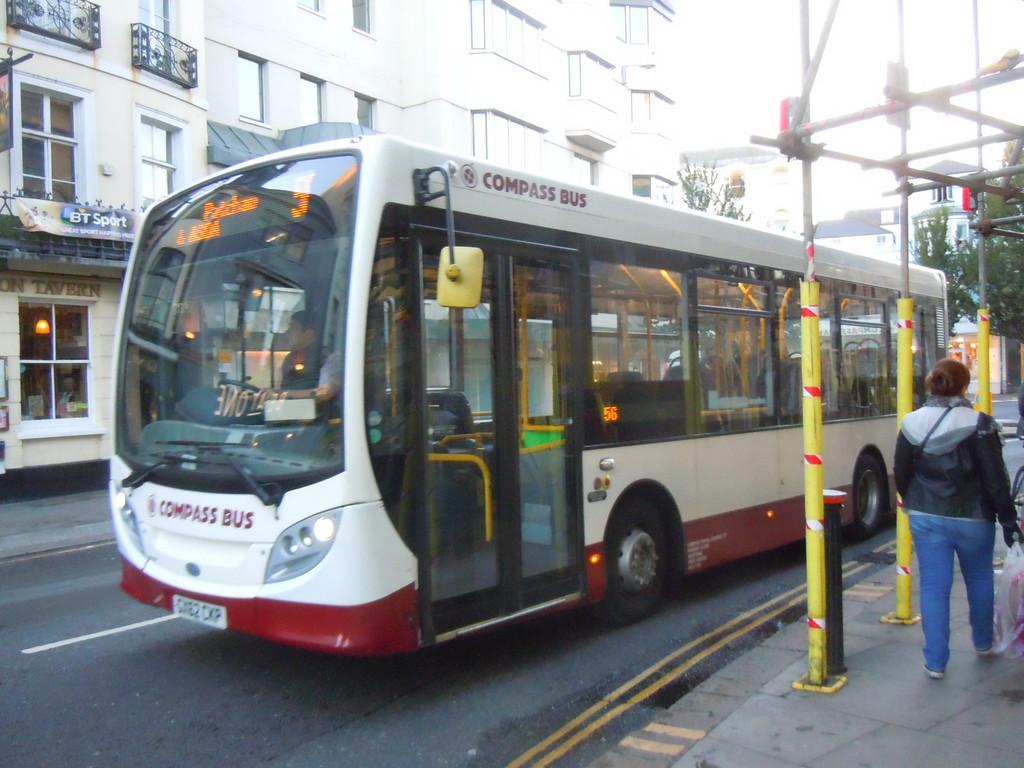Please provide a concise description of this image. This picture is clicked outside the city. In the middle of the picture, we see a bus in white and red color is moving on the road. We see a man is riding the bus. Beside that, we see the poles and a woman in the black jacket is walking on the footpath. On the right side, we see the trees. On the left side, we see the buildings and the railing. There are trees and buildings in the background. At the bottom, we see the road. 